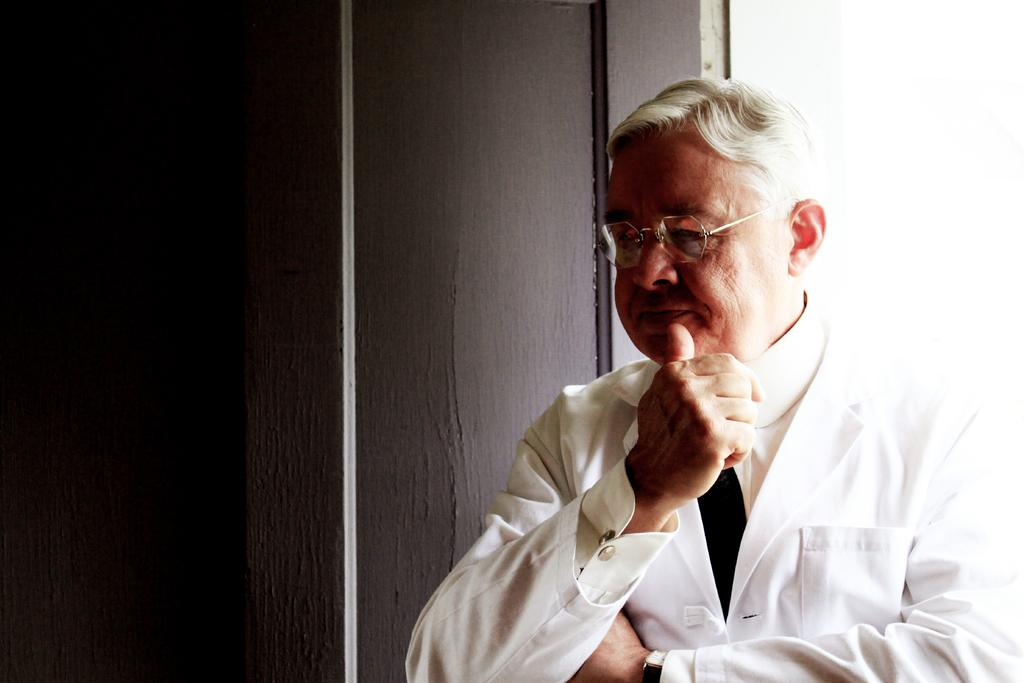Who is present in the image? There is a man in the image. What is the man doing in the image? The man is standing beside a wall. What type of desk is the man using for punishment in the image? There is no desk or punishment present in the image; it only features a man standing beside a wall. 